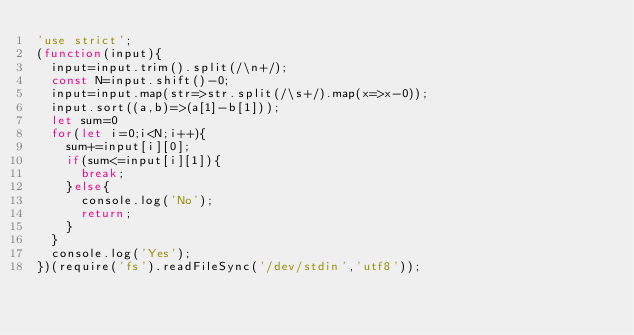<code> <loc_0><loc_0><loc_500><loc_500><_JavaScript_>'use strict';
(function(input){
  input=input.trim().split(/\n+/);
  const N=input.shift()-0;
  input=input.map(str=>str.split(/\s+/).map(x=>x-0));
  input.sort((a,b)=>(a[1]-b[1]));
  let sum=0
  for(let i=0;i<N;i++){
    sum+=input[i][0];
    if(sum<=input[i][1]){
      break;
    }else{
      console.log('No');
      return;
    }
  }
  console.log('Yes');
})(require('fs').readFileSync('/dev/stdin','utf8'));</code> 